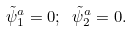<formula> <loc_0><loc_0><loc_500><loc_500>\tilde { \psi } _ { 1 } ^ { a } = 0 ; \ \tilde { \psi } _ { 2 } ^ { a } = 0 .</formula> 